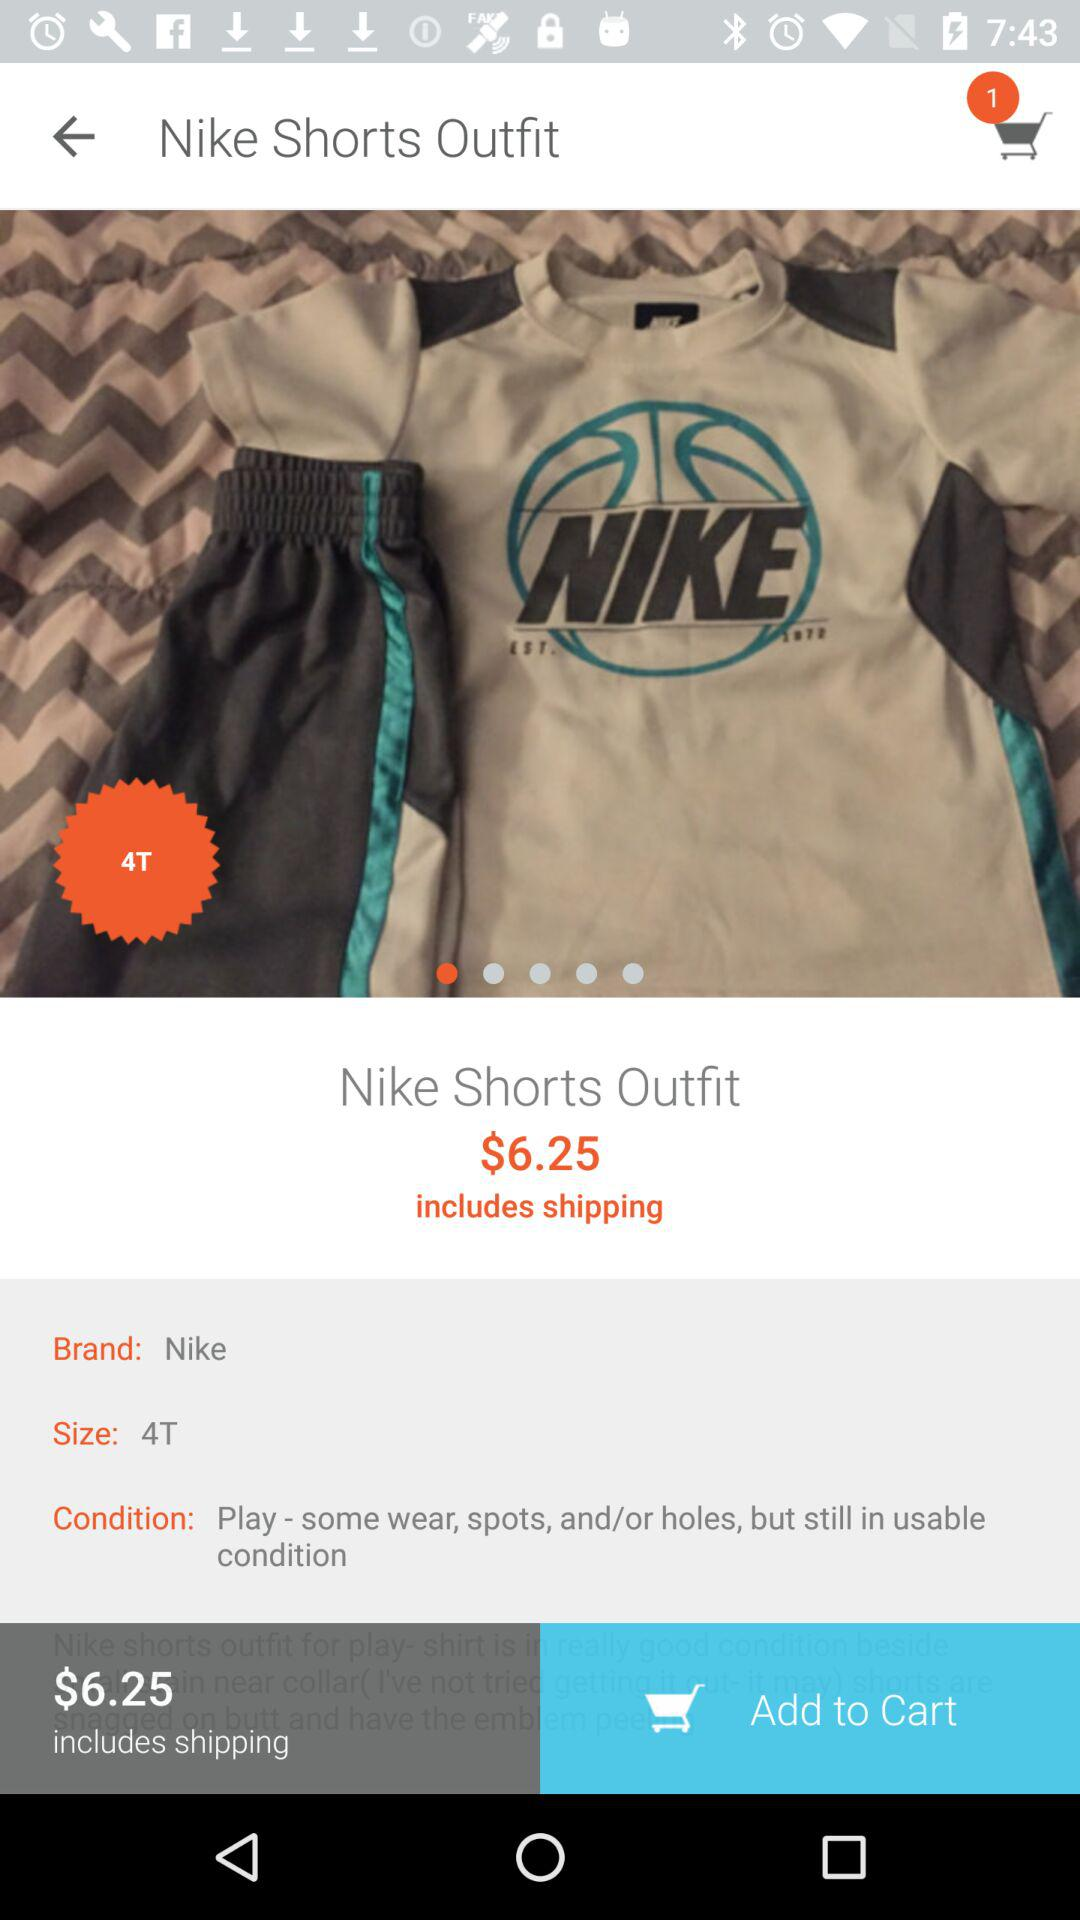Does price include shipping charges?
When the provided information is insufficient, respond with <no answer>. <no answer> 